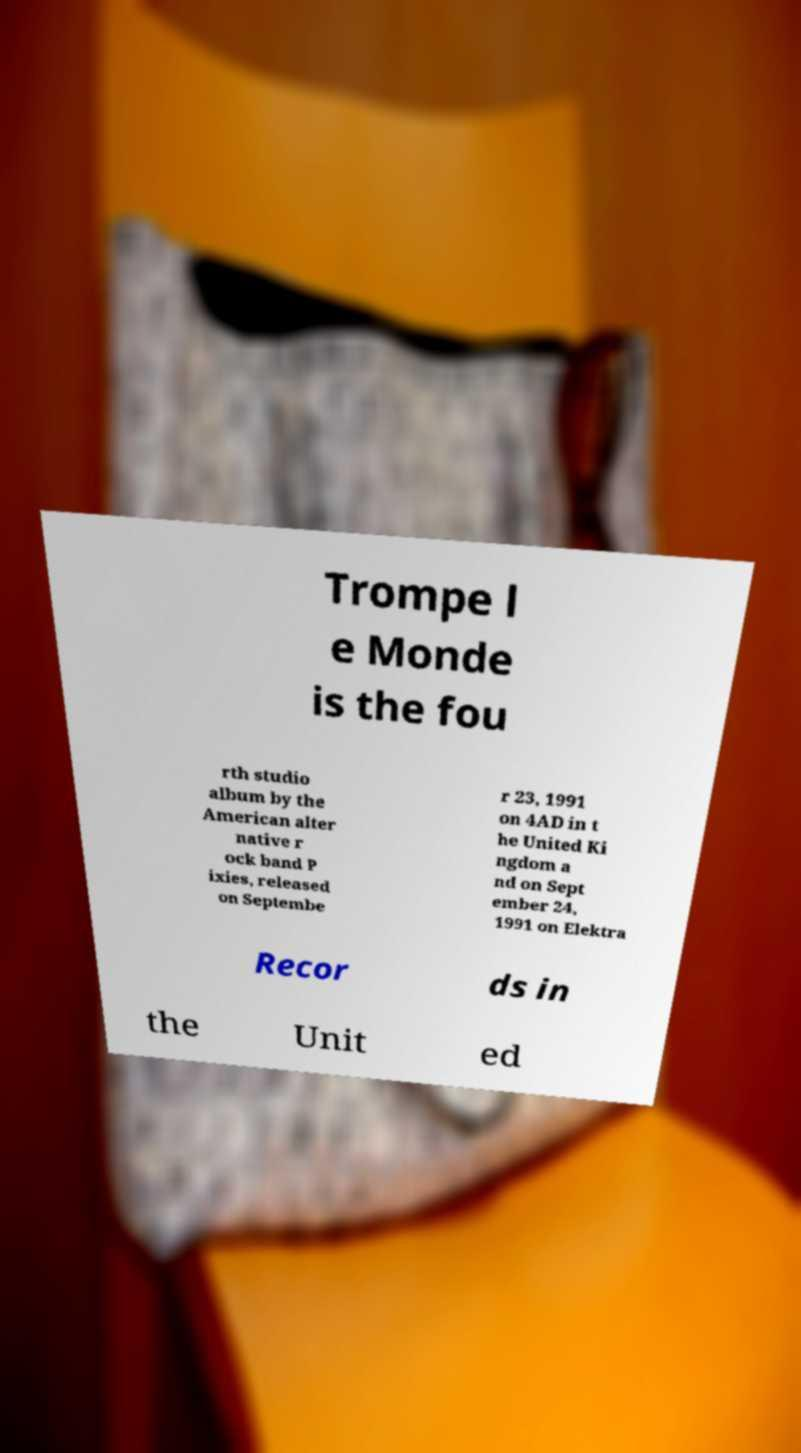For documentation purposes, I need the text within this image transcribed. Could you provide that? Trompe l e Monde is the fou rth studio album by the American alter native r ock band P ixies, released on Septembe r 23, 1991 on 4AD in t he United Ki ngdom a nd on Sept ember 24, 1991 on Elektra Recor ds in the Unit ed 